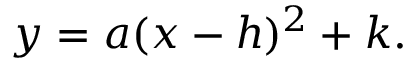Convert formula to latex. <formula><loc_0><loc_0><loc_500><loc_500>y = a ( x - h ) ^ { 2 } + k .</formula> 